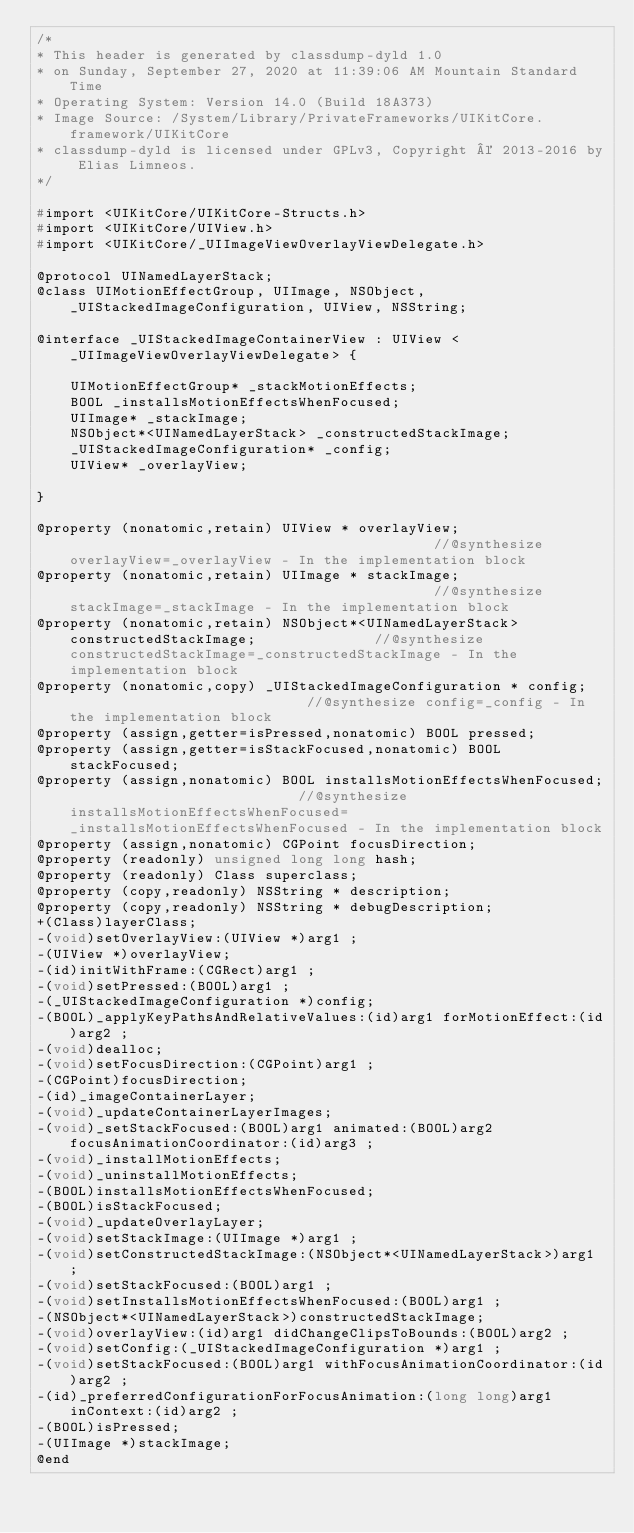<code> <loc_0><loc_0><loc_500><loc_500><_C_>/*
* This header is generated by classdump-dyld 1.0
* on Sunday, September 27, 2020 at 11:39:06 AM Mountain Standard Time
* Operating System: Version 14.0 (Build 18A373)
* Image Source: /System/Library/PrivateFrameworks/UIKitCore.framework/UIKitCore
* classdump-dyld is licensed under GPLv3, Copyright © 2013-2016 by Elias Limneos.
*/

#import <UIKitCore/UIKitCore-Structs.h>
#import <UIKitCore/UIView.h>
#import <UIKitCore/_UIImageViewOverlayViewDelegate.h>

@protocol UINamedLayerStack;
@class UIMotionEffectGroup, UIImage, NSObject, _UIStackedImageConfiguration, UIView, NSString;

@interface _UIStackedImageContainerView : UIView <_UIImageViewOverlayViewDelegate> {

	UIMotionEffectGroup* _stackMotionEffects;
	BOOL _installsMotionEffectsWhenFocused;
	UIImage* _stackImage;
	NSObject*<UINamedLayerStack> _constructedStackImage;
	_UIStackedImageConfiguration* _config;
	UIView* _overlayView;

}

@property (nonatomic,retain) UIView * overlayView;                                            //@synthesize overlayView=_overlayView - In the implementation block
@property (nonatomic,retain) UIImage * stackImage;                                            //@synthesize stackImage=_stackImage - In the implementation block
@property (nonatomic,retain) NSObject*<UINamedLayerStack> constructedStackImage;              //@synthesize constructedStackImage=_constructedStackImage - In the implementation block
@property (nonatomic,copy) _UIStackedImageConfiguration * config;                             //@synthesize config=_config - In the implementation block
@property (assign,getter=isPressed,nonatomic) BOOL pressed; 
@property (assign,getter=isStackFocused,nonatomic) BOOL stackFocused; 
@property (assign,nonatomic) BOOL installsMotionEffectsWhenFocused;                           //@synthesize installsMotionEffectsWhenFocused=_installsMotionEffectsWhenFocused - In the implementation block
@property (assign,nonatomic) CGPoint focusDirection; 
@property (readonly) unsigned long long hash; 
@property (readonly) Class superclass; 
@property (copy,readonly) NSString * description; 
@property (copy,readonly) NSString * debugDescription; 
+(Class)layerClass;
-(void)setOverlayView:(UIView *)arg1 ;
-(UIView *)overlayView;
-(id)initWithFrame:(CGRect)arg1 ;
-(void)setPressed:(BOOL)arg1 ;
-(_UIStackedImageConfiguration *)config;
-(BOOL)_applyKeyPathsAndRelativeValues:(id)arg1 forMotionEffect:(id)arg2 ;
-(void)dealloc;
-(void)setFocusDirection:(CGPoint)arg1 ;
-(CGPoint)focusDirection;
-(id)_imageContainerLayer;
-(void)_updateContainerLayerImages;
-(void)_setStackFocused:(BOOL)arg1 animated:(BOOL)arg2 focusAnimationCoordinator:(id)arg3 ;
-(void)_installMotionEffects;
-(void)_uninstallMotionEffects;
-(BOOL)installsMotionEffectsWhenFocused;
-(BOOL)isStackFocused;
-(void)_updateOverlayLayer;
-(void)setStackImage:(UIImage *)arg1 ;
-(void)setConstructedStackImage:(NSObject*<UINamedLayerStack>)arg1 ;
-(void)setStackFocused:(BOOL)arg1 ;
-(void)setInstallsMotionEffectsWhenFocused:(BOOL)arg1 ;
-(NSObject*<UINamedLayerStack>)constructedStackImage;
-(void)overlayView:(id)arg1 didChangeClipsToBounds:(BOOL)arg2 ;
-(void)setConfig:(_UIStackedImageConfiguration *)arg1 ;
-(void)setStackFocused:(BOOL)arg1 withFocusAnimationCoordinator:(id)arg2 ;
-(id)_preferredConfigurationForFocusAnimation:(long long)arg1 inContext:(id)arg2 ;
-(BOOL)isPressed;
-(UIImage *)stackImage;
@end

</code> 